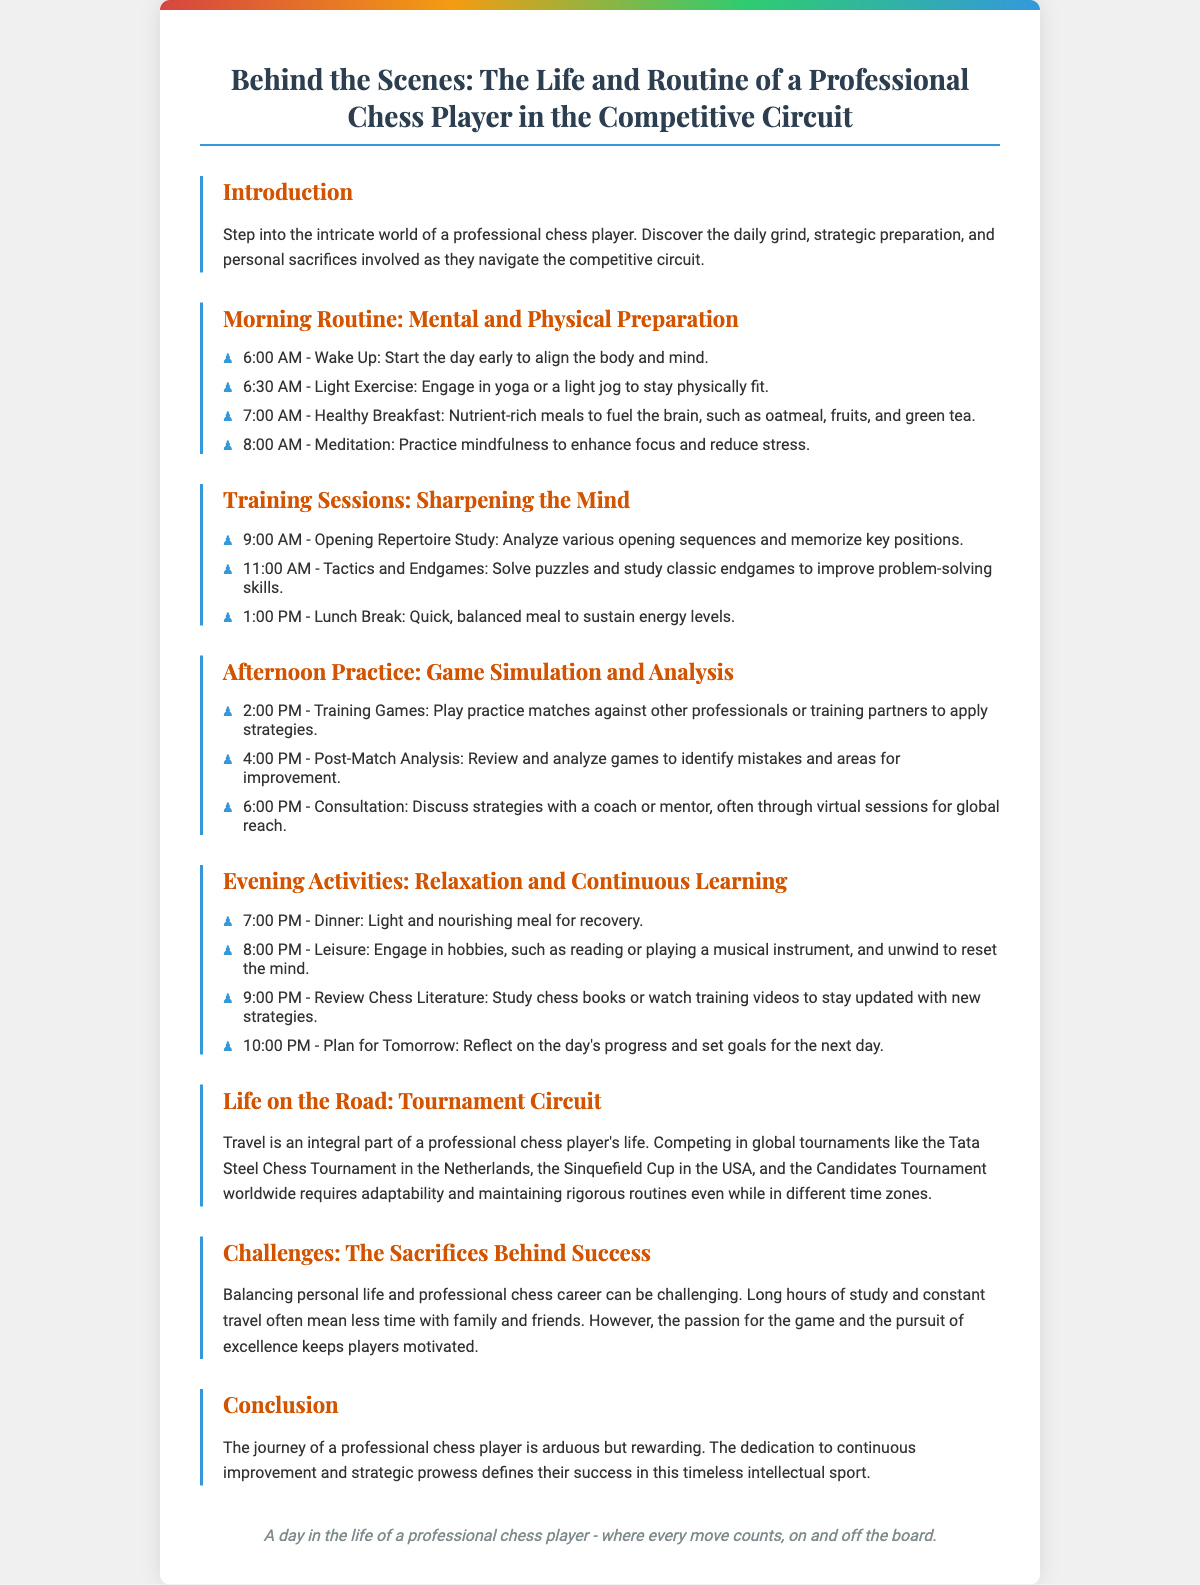What time does the professional chess player wake up? The document states that the player wakes up at 6:00 AM.
Answer: 6:00 AM What activity is performed at 8:00 AM? At this time, the player practices mindfulness through meditation to enhance focus and reduce stress.
Answer: Meditation What is included in the training sessions? The document mentions the study of opening repertoire, tactics, and endgames during training sessions.
Answer: Opening repertoire study, tactics, and endgames How many hours are typically devoted to morning routines? The morning routine is outlined from 6:00 AM to 8:00 AM, which is 2 hours.
Answer: 2 hours What types of meals are consumed in the evening activities? The evening activities include dinner as a light and nourishing meal for recovery.
Answer: Light and nourishing meal What global tournament is mentioned in the section about the tournament circuit? The Tata Steel Chess Tournament in the Netherlands is one of the tournaments referenced.
Answer: Tata Steel Chess Tournament What is a major challenge faced by professional chess players according to the document? The document highlights that balancing personal life and professional chess career can be very challenging.
Answer: Balancing personal life and career What does the footer of the playbill summarize about a day in the life of a chess player? The footer states that every move counts, both on and off the board, emphasizing the importance of each decision.
Answer: Every move counts, on and off the board 